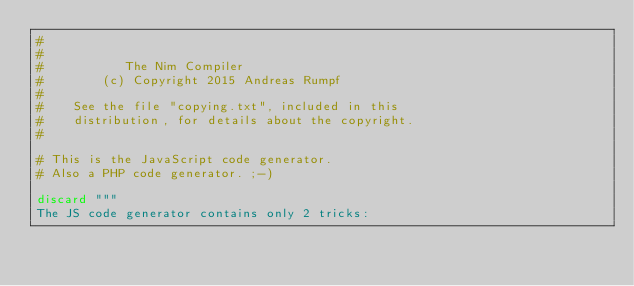<code> <loc_0><loc_0><loc_500><loc_500><_Nim_>#
#
#           The Nim Compiler
#        (c) Copyright 2015 Andreas Rumpf
#
#    See the file "copying.txt", included in this
#    distribution, for details about the copyright.
#

# This is the JavaScript code generator.
# Also a PHP code generator. ;-)

discard """
The JS code generator contains only 2 tricks:
</code> 